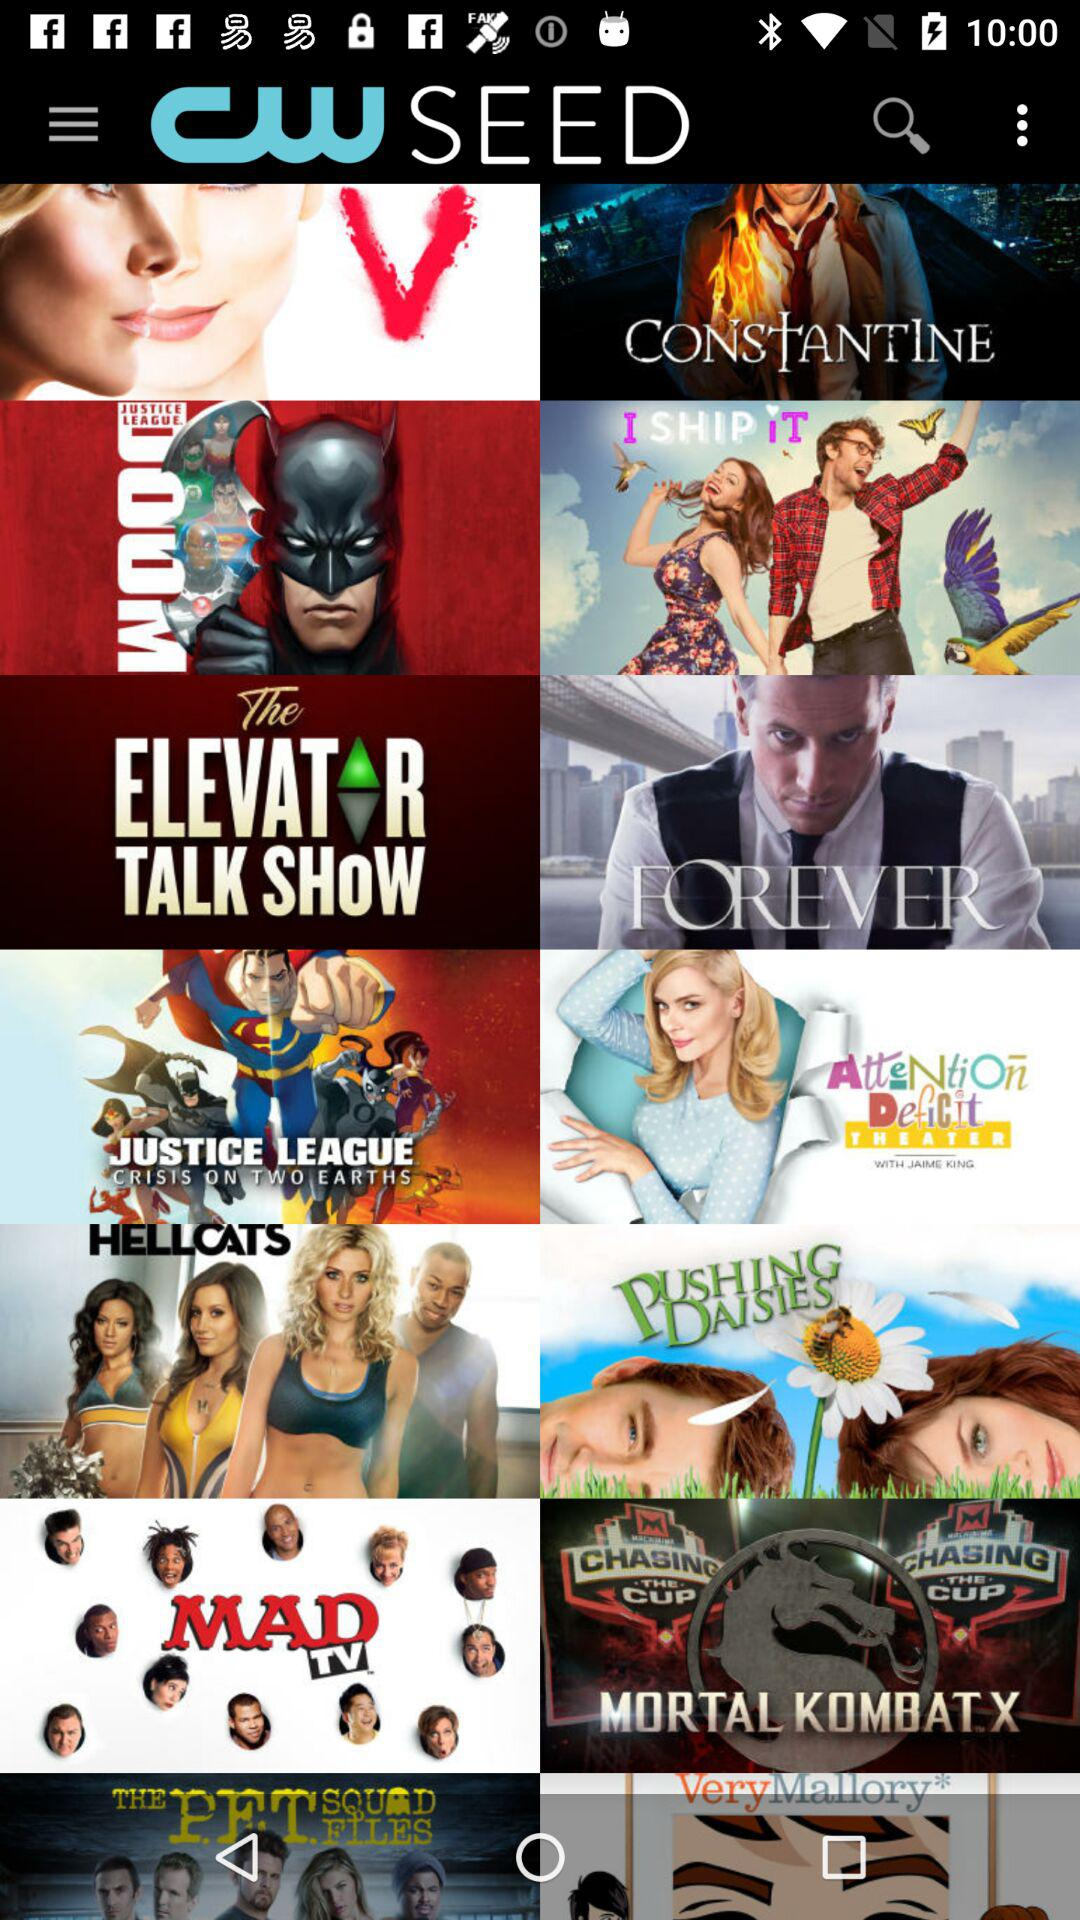How long does "FOREVER" last?
When the provided information is insufficient, respond with <no answer>. <no answer> 